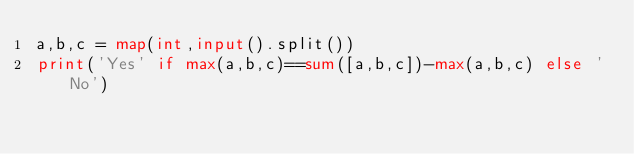<code> <loc_0><loc_0><loc_500><loc_500><_Python_>a,b,c = map(int,input().split())
print('Yes' if max(a,b,c)==sum([a,b,c])-max(a,b,c) else 'No')</code> 